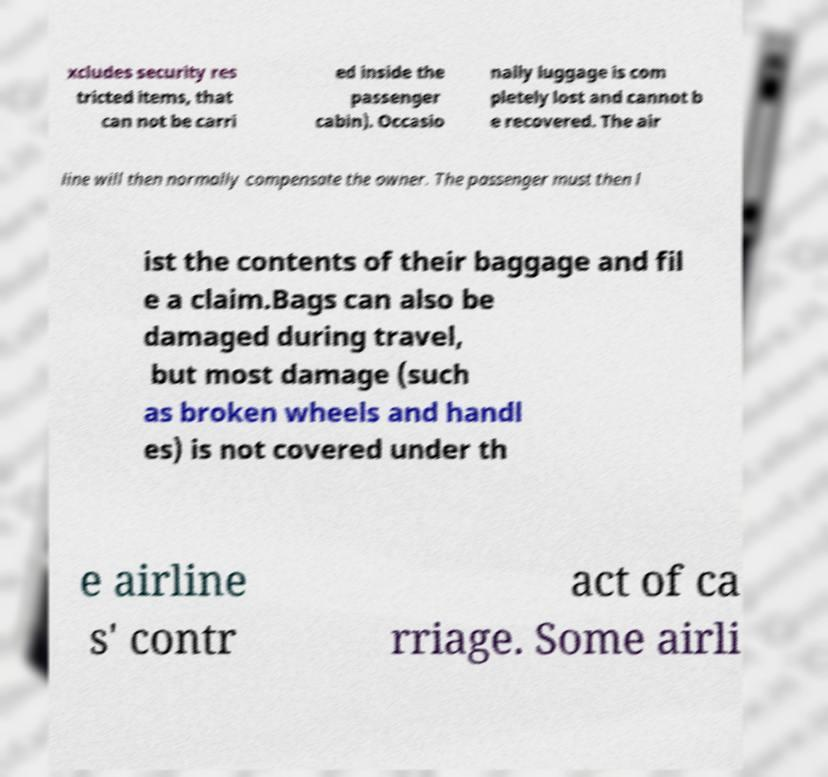There's text embedded in this image that I need extracted. Can you transcribe it verbatim? xcludes security res tricted items, that can not be carri ed inside the passenger cabin). Occasio nally luggage is com pletely lost and cannot b e recovered. The air line will then normally compensate the owner. The passenger must then l ist the contents of their baggage and fil e a claim.Bags can also be damaged during travel, but most damage (such as broken wheels and handl es) is not covered under th e airline s' contr act of ca rriage. Some airli 